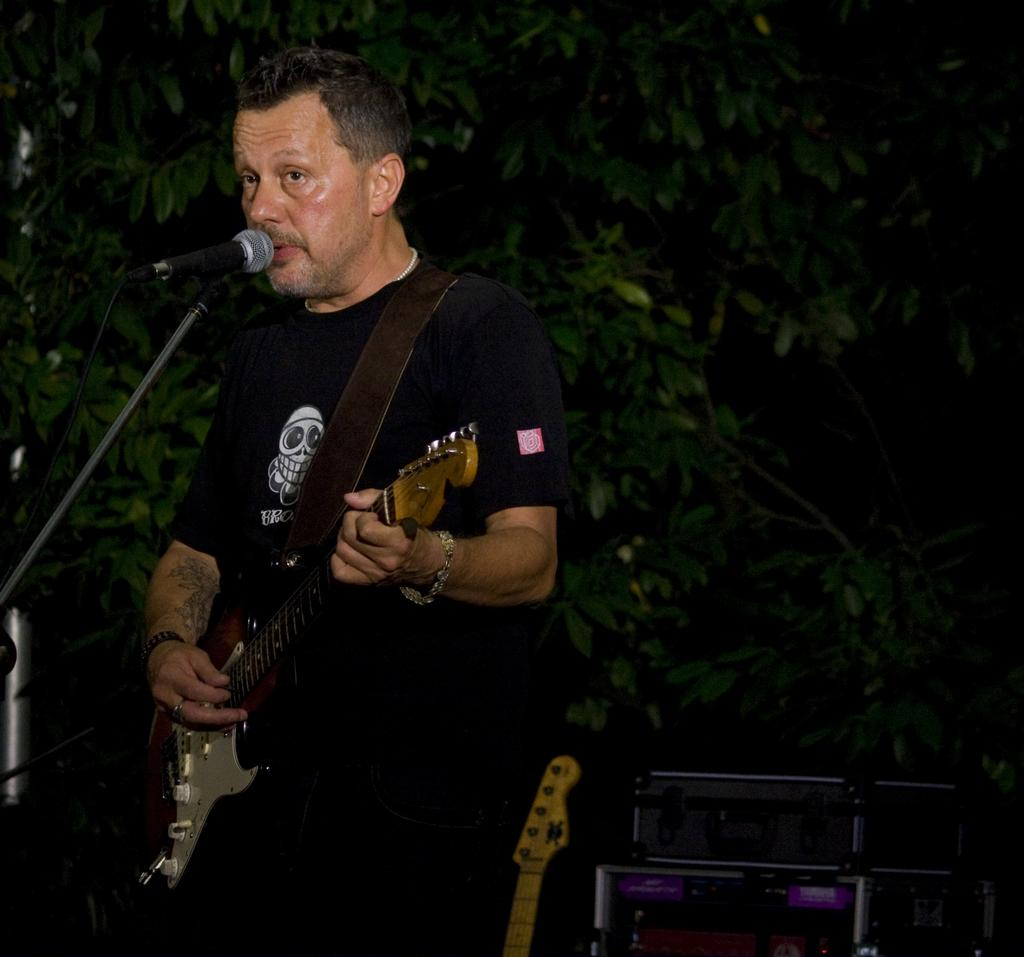What is the main subject of the image? The main subject of the image is a man. What is the man doing in the image? The man is standing and holding a guitar in his hand. Are there any other objects or equipment in the image? Yes, there are microphones in the image. What can be seen in the background of the image? There is a tree visible in the background of the image. What type of yarn is the man using to play the guitar in the image? There is no yarn present in the image, and the man is not using any yarn to play the guitar. 